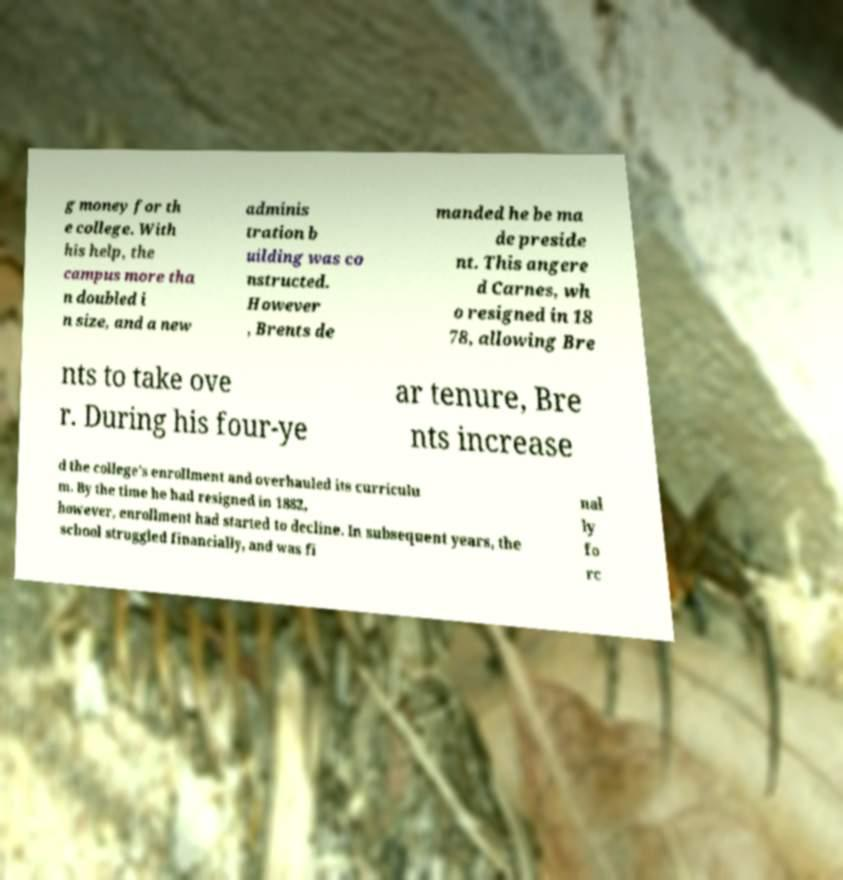Please read and relay the text visible in this image. What does it say? g money for th e college. With his help, the campus more tha n doubled i n size, and a new adminis tration b uilding was co nstructed. However , Brents de manded he be ma de preside nt. This angere d Carnes, wh o resigned in 18 78, allowing Bre nts to take ove r. During his four-ye ar tenure, Bre nts increase d the college's enrollment and overhauled its curriculu m. By the time he had resigned in 1882, however, enrollment had started to decline. In subsequent years, the school struggled financially, and was fi nal ly fo rc 